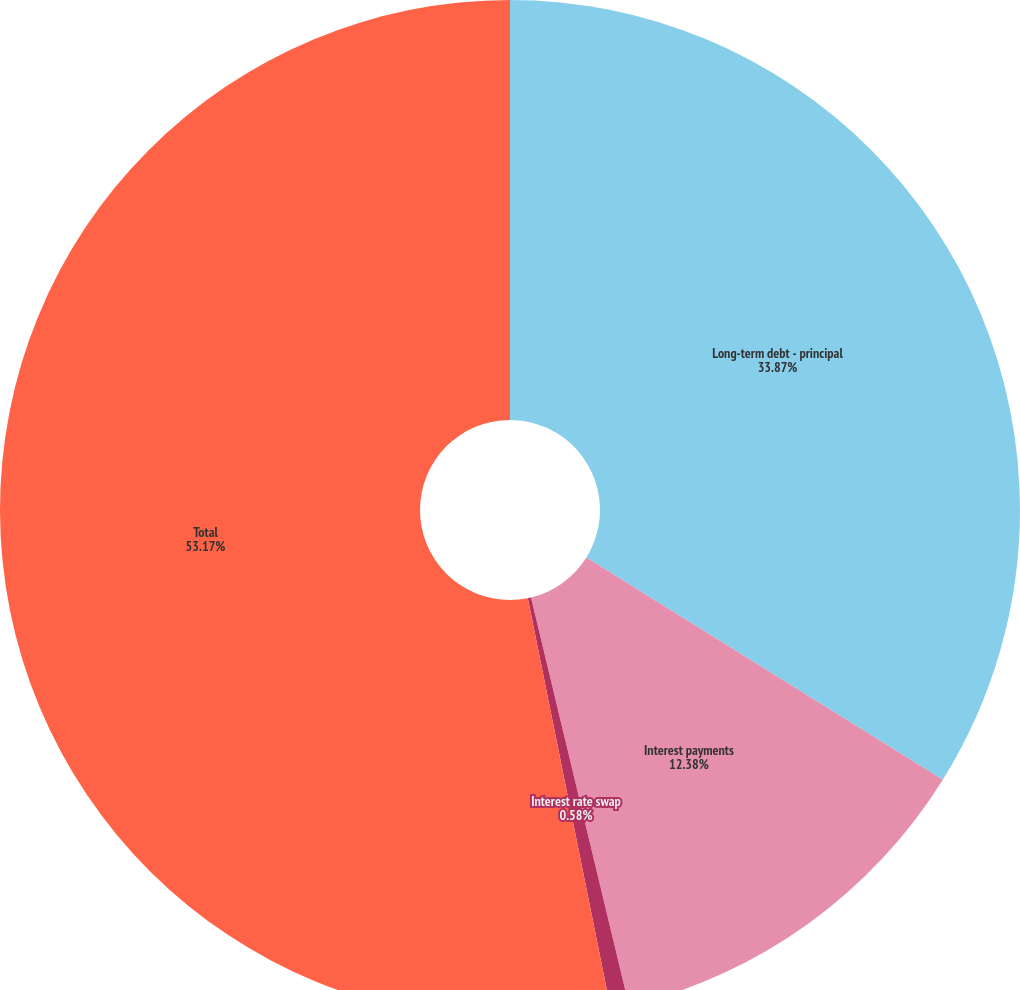<chart> <loc_0><loc_0><loc_500><loc_500><pie_chart><fcel>Long-term debt - principal<fcel>Interest payments<fcel>Interest rate swap<fcel>Total<nl><fcel>33.87%<fcel>12.38%<fcel>0.58%<fcel>53.17%<nl></chart> 